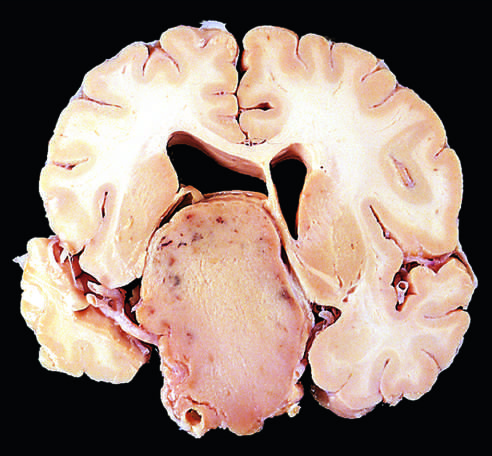what do nonfunctioning adenomas tend to be?
Answer the question using a single word or phrase. Larger at the time of diagnosis than those that secrete hormone 